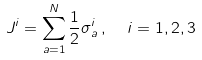Convert formula to latex. <formula><loc_0><loc_0><loc_500><loc_500>J ^ { i } = \sum _ { a = 1 } ^ { N } \frac { 1 } { 2 } \sigma ^ { i } _ { a } \, , \ \ i = 1 , 2 , 3</formula> 